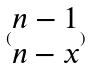Convert formula to latex. <formula><loc_0><loc_0><loc_500><loc_500>( \begin{matrix} n - 1 \\ n - x \end{matrix} )</formula> 